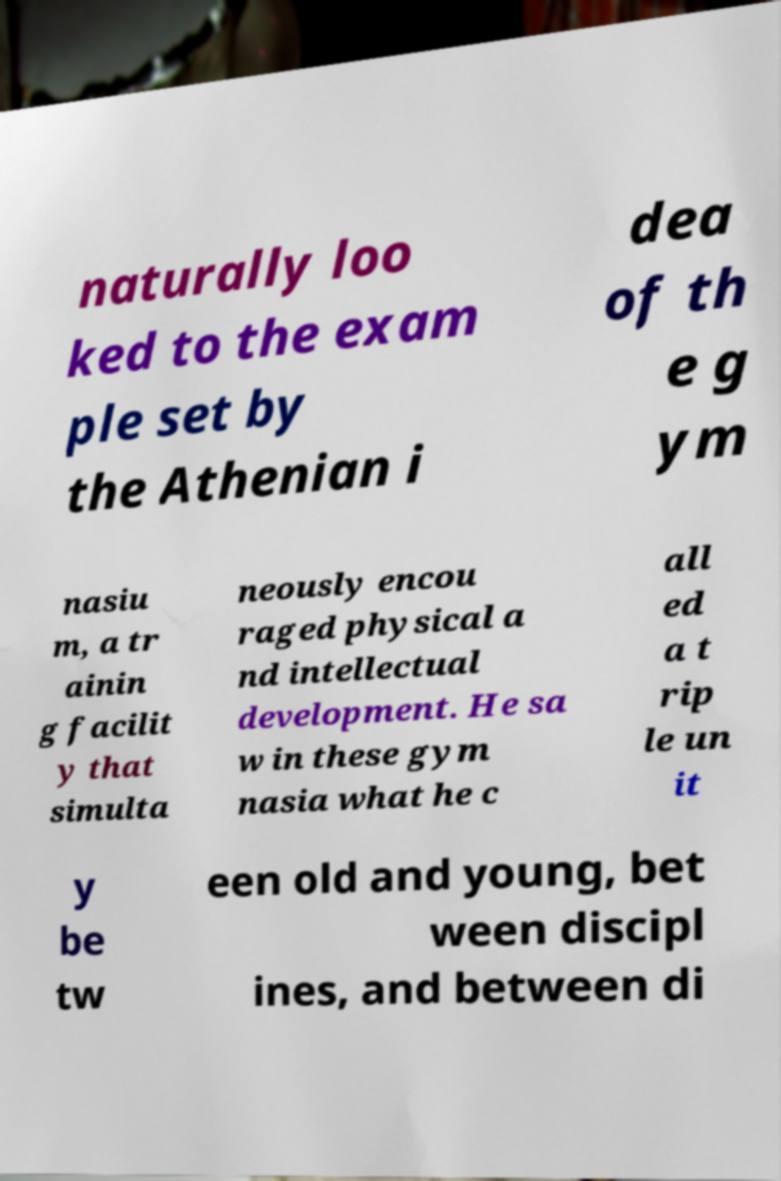Could you assist in decoding the text presented in this image and type it out clearly? naturally loo ked to the exam ple set by the Athenian i dea of th e g ym nasiu m, a tr ainin g facilit y that simulta neously encou raged physical a nd intellectual development. He sa w in these gym nasia what he c all ed a t rip le un it y be tw een old and young, bet ween discipl ines, and between di 